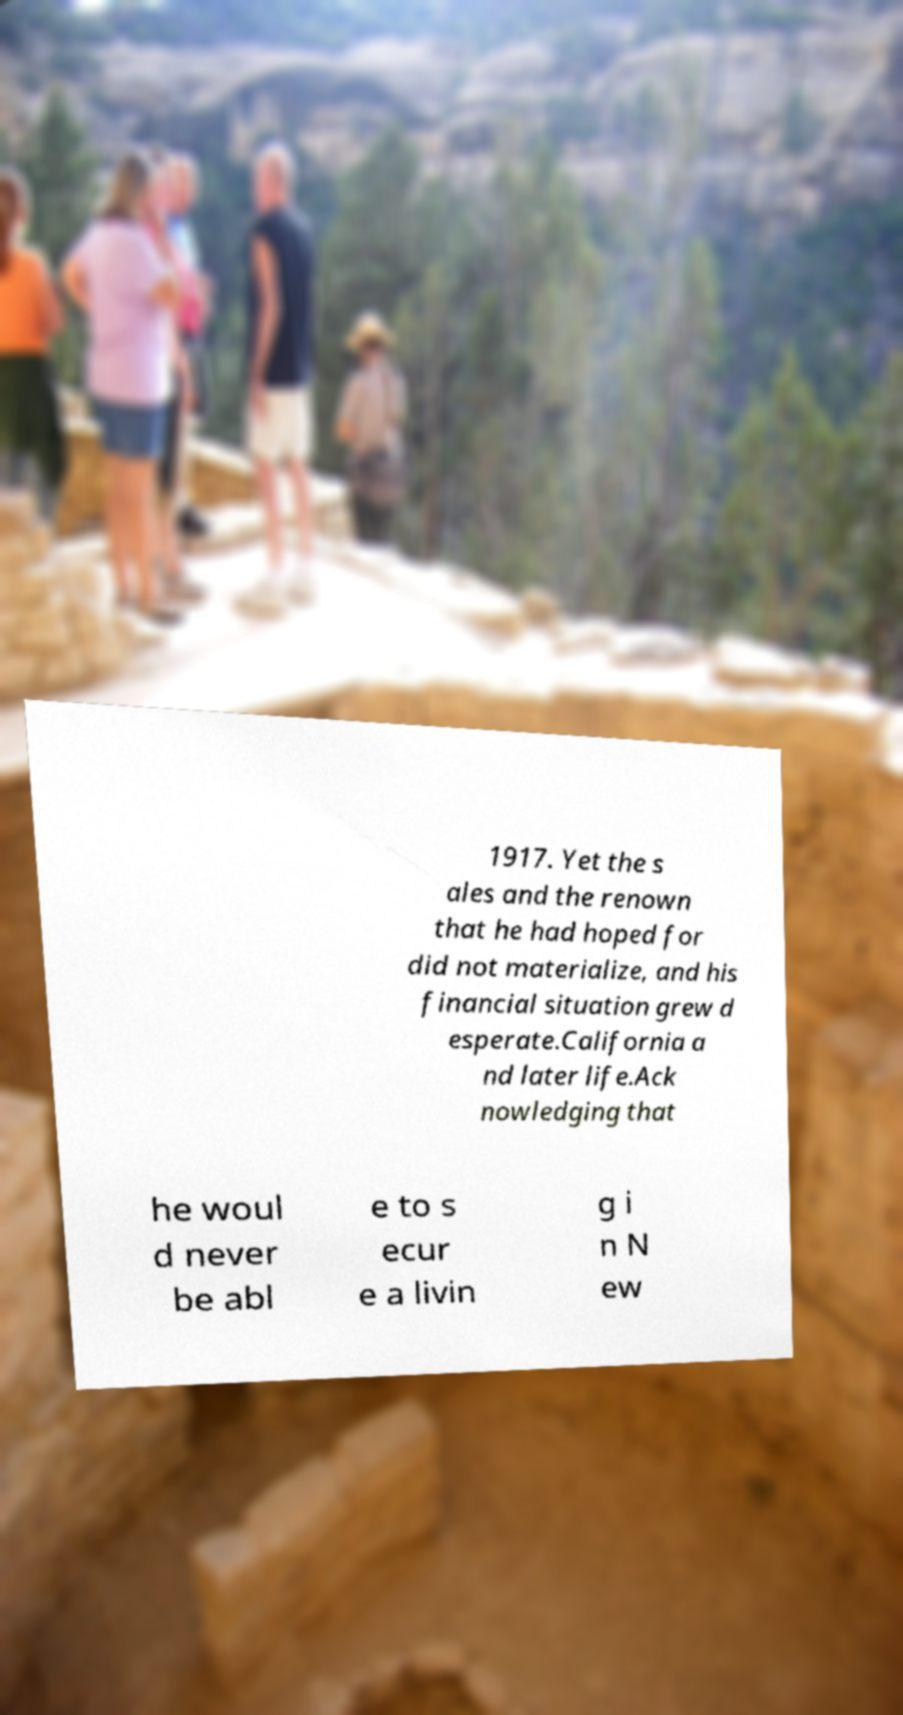Please identify and transcribe the text found in this image. 1917. Yet the s ales and the renown that he had hoped for did not materialize, and his financial situation grew d esperate.California a nd later life.Ack nowledging that he woul d never be abl e to s ecur e a livin g i n N ew 